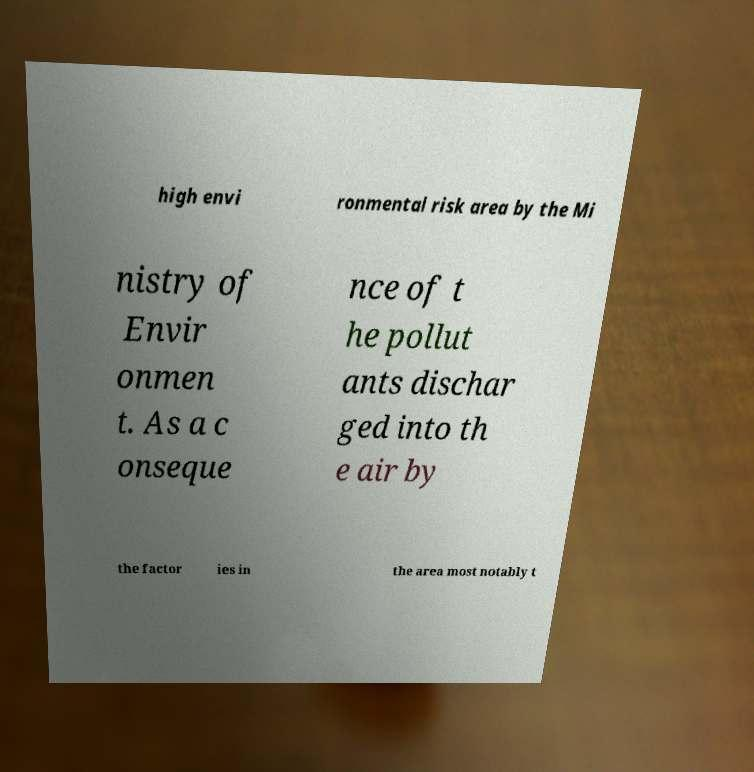Can you read and provide the text displayed in the image?This photo seems to have some interesting text. Can you extract and type it out for me? high envi ronmental risk area by the Mi nistry of Envir onmen t. As a c onseque nce of t he pollut ants dischar ged into th e air by the factor ies in the area most notably t 